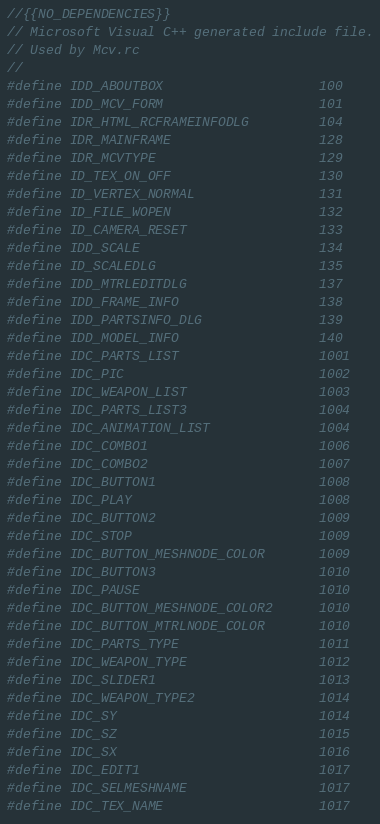<code> <loc_0><loc_0><loc_500><loc_500><_C_>//{{NO_DEPENDENCIES}}
// Microsoft Visual C++ generated include file.
// Used by Mcv.rc
//
#define IDD_ABOUTBOX                    100
#define IDD_MCV_FORM                    101
#define IDR_HTML_RCFRAMEINFODLG         104
#define IDR_MAINFRAME                   128
#define IDR_MCVTYPE                     129
#define ID_TEX_ON_OFF                   130
#define ID_VERTEX_NORMAL                131
#define ID_FILE_WOPEN                   132
#define ID_CAMERA_RESET                 133
#define IDD_SCALE                       134
#define ID_SCALEDLG                     135
#define IDD_MTRLEDITDLG                 137
#define IDD_FRAME_INFO                  138
#define IDD_PARTSINFO_DLG               139
#define IDD_MODEL_INFO                  140
#define IDC_PARTS_LIST                  1001
#define IDC_PIC                         1002
#define IDC_WEAPON_LIST                 1003
#define IDC_PARTS_LIST3                 1004
#define IDC_ANIMATION_LIST              1004
#define IDC_COMBO1                      1006
#define IDC_COMBO2                      1007
#define IDC_BUTTON1                     1008
#define IDC_PLAY                        1008
#define IDC_BUTTON2                     1009
#define IDC_STOP                        1009
#define IDC_BUTTON_MESHNODE_COLOR       1009
#define IDC_BUTTON3                     1010
#define IDC_PAUSE                       1010
#define IDC_BUTTON_MESHNODE_COLOR2      1010
#define IDC_BUTTON_MTRLNODE_COLOR       1010
#define IDC_PARTS_TYPE                  1011
#define IDC_WEAPON_TYPE                 1012
#define IDC_SLIDER1                     1013
#define IDC_WEAPON_TYPE2                1014
#define IDC_SY                          1014
#define IDC_SZ                          1015
#define IDC_SX                          1016
#define IDC_EDIT1                       1017
#define IDC_SELMESHNAME                 1017
#define IDC_TEX_NAME                    1017</code> 